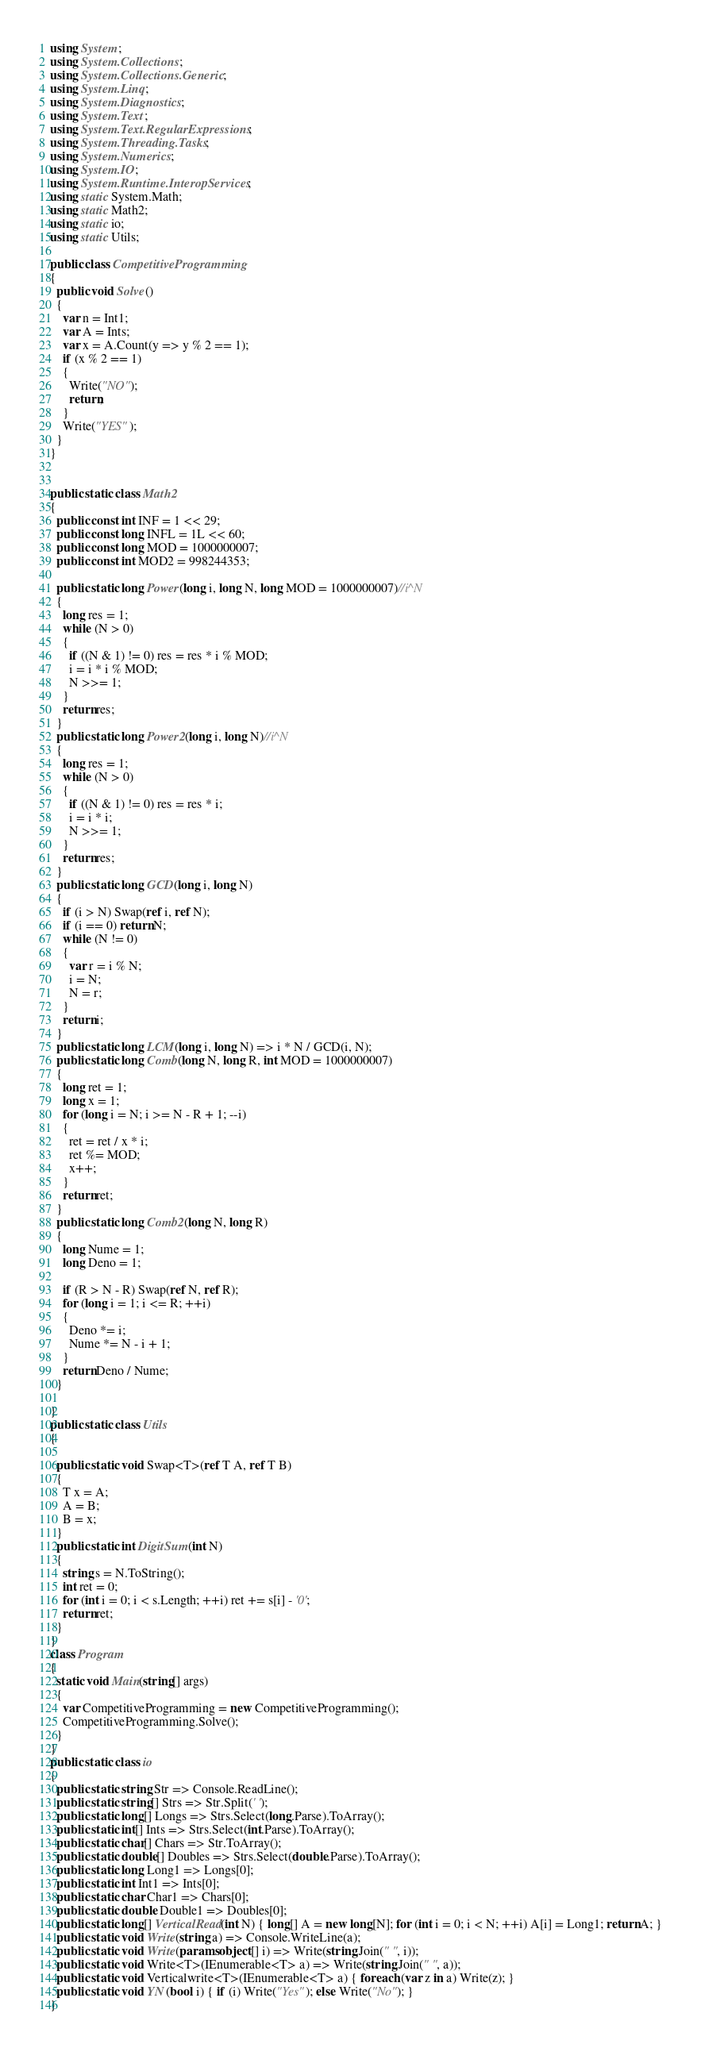Convert code to text. <code><loc_0><loc_0><loc_500><loc_500><_C#_>using System;
using System.Collections;
using System.Collections.Generic;
using System.Linq;
using System.Diagnostics;
using System.Text;
using System.Text.RegularExpressions;
using System.Threading.Tasks;
using System.Numerics;
using System.IO;
using System.Runtime.InteropServices;
using static System.Math;
using static Math2;
using static io;
using static Utils;

public class CompetitiveProgramming
{
  public void Solve()
  {
    var n = Int1;
    var A = Ints;
    var x = A.Count(y => y % 2 == 1);
    if (x % 2 == 1)
    {
      Write("NO");
      return;
    }
    Write("YES");
  }
}


public static class Math2
{
  public const int INF = 1 << 29;
  public const long INFL = 1L << 60;
  public const long MOD = 1000000007;
  public const int MOD2 = 998244353;

  public static long Power(long i, long N, long MOD = 1000000007)//i^N
  {
    long res = 1;
    while (N > 0)
    {
      if ((N & 1) != 0) res = res * i % MOD;
      i = i * i % MOD;
      N >>= 1;
    }
    return res;
  }
  public static long Power2(long i, long N)//i^N
  {
    long res = 1;
    while (N > 0)
    {
      if ((N & 1) != 0) res = res * i;
      i = i * i;
      N >>= 1;
    }
    return res;
  }
  public static long GCD(long i, long N)
  {
    if (i > N) Swap(ref i, ref N);
    if (i == 0) return N;
    while (N != 0)
    {
      var r = i % N;
      i = N;
      N = r;
    }
    return i;
  }
  public static long LCM(long i, long N) => i * N / GCD(i, N);
  public static long Comb(long N, long R, int MOD = 1000000007)
  {
    long ret = 1;
    long x = 1;
    for (long i = N; i >= N - R + 1; --i)
    {
      ret = ret / x * i;
      ret %= MOD;
      x++;
    }
    return ret;
  }
  public static long Comb2(long N, long R)
  {
    long Nume = 1;
    long Deno = 1;

    if (R > N - R) Swap(ref N, ref R);
    for (long i = 1; i <= R; ++i)
    {
      Deno *= i;
      Nume *= N - i + 1;
    }
    return Deno / Nume;
  }

}
public static class Utils
{

  public static void Swap<T>(ref T A, ref T B)
  {
    T x = A;
    A = B;
    B = x;
  }
  public static int DigitSum(int N)
  {
    string s = N.ToString();
    int ret = 0;
    for (int i = 0; i < s.Length; ++i) ret += s[i] - '0';
    return ret;
  }
}
class Program
{
  static void Main(string[] args)
  {
    var CompetitiveProgramming = new CompetitiveProgramming();
    CompetitiveProgramming.Solve();
  }
}
public static class io
{
  public static string Str => Console.ReadLine();
  public static string[] Strs => Str.Split(' ');
  public static long[] Longs => Strs.Select(long.Parse).ToArray();
  public static int[] Ints => Strs.Select(int.Parse).ToArray();
  public static char[] Chars => Str.ToArray();
  public static double[] Doubles => Strs.Select(double.Parse).ToArray();
  public static long Long1 => Longs[0];
  public static int Int1 => Ints[0];
  public static char Char1 => Chars[0];
  public static double Double1 => Doubles[0];
  public static long[] VerticalRead(int N) { long[] A = new long[N]; for (int i = 0; i < N; ++i) A[i] = Long1; return A; }
  public static void Write(string a) => Console.WriteLine(a);
  public static void Write(params object[] i) => Write(string.Join(" ", i));
  public static void Write<T>(IEnumerable<T> a) => Write(string.Join(" ", a));
  public static void Verticalwrite<T>(IEnumerable<T> a) { foreach (var z in a) Write(z); }
  public static void YN(bool i) { if (i) Write("Yes"); else Write("No"); }
}
</code> 